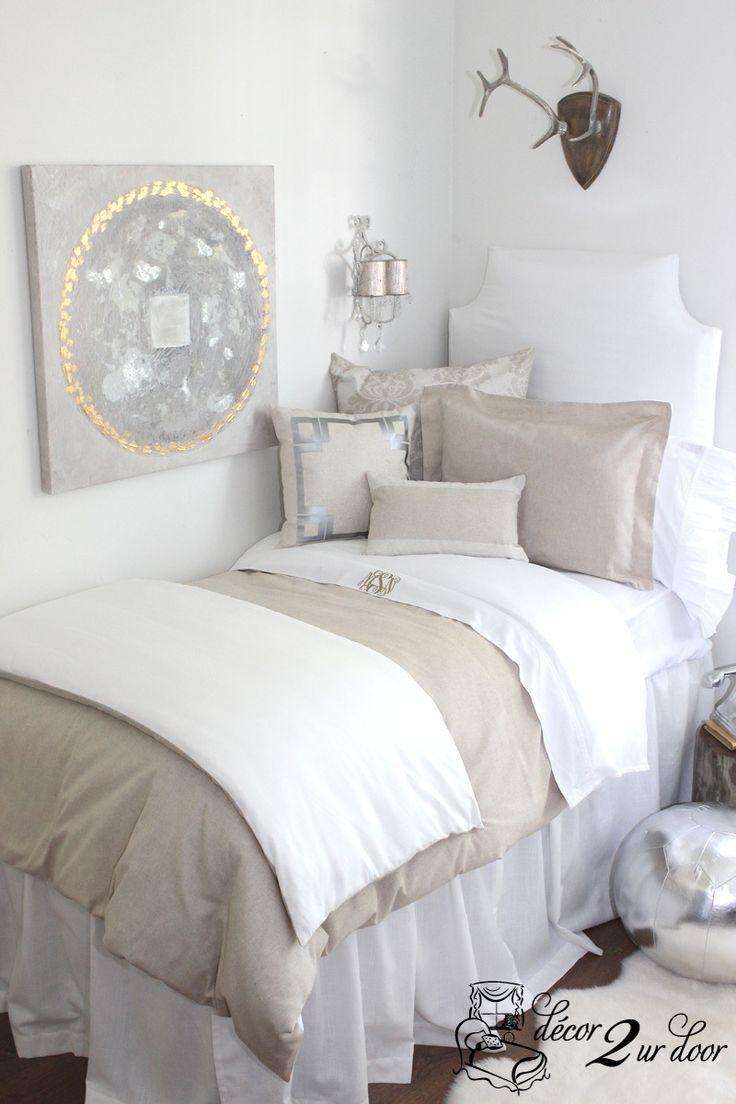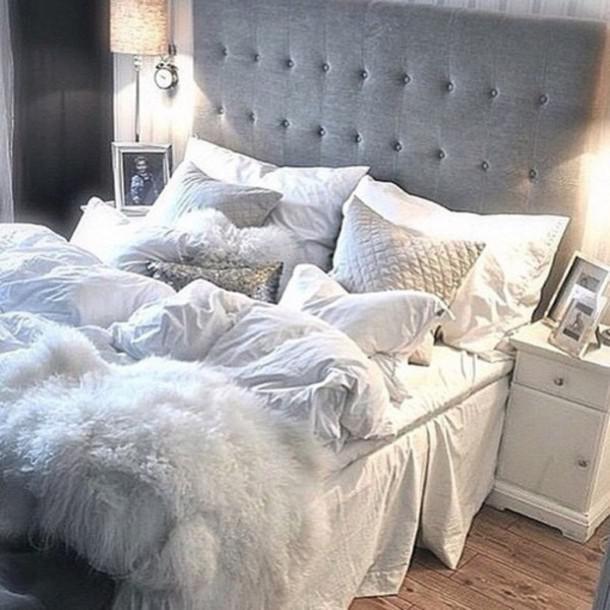The first image is the image on the left, the second image is the image on the right. Given the left and right images, does the statement "An image features a pillow-piled bed with a neutral-colored tufted headboard." hold true? Answer yes or no. Yes. 